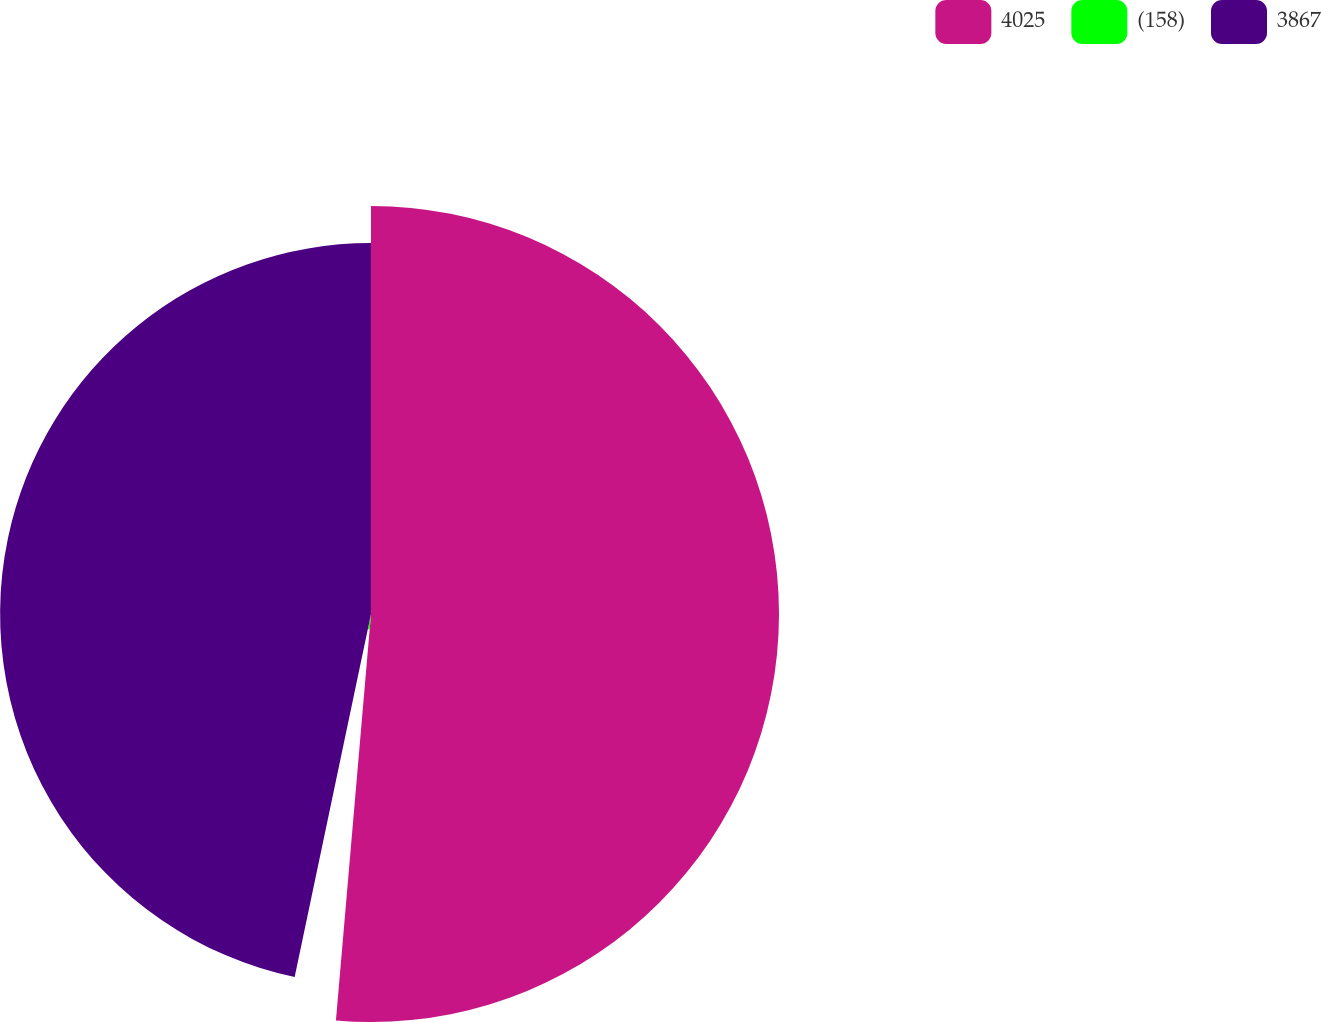Convert chart to OTSL. <chart><loc_0><loc_0><loc_500><loc_500><pie_chart><fcel>4025<fcel>(158)<fcel>3867<nl><fcel>51.37%<fcel>1.93%<fcel>46.7%<nl></chart> 